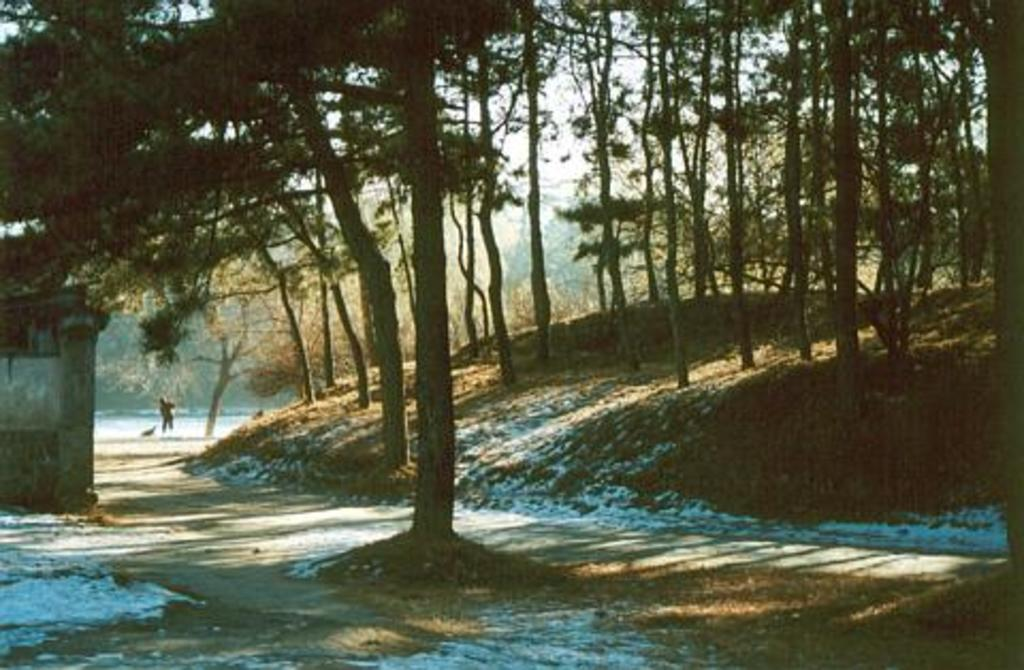What type of natural elements can be seen in the image? There are trees in the image. What type of structure is present in the image? There is a house in the image. Who is present in the image? There is a man in the image. What is the man doing in the image? The man is using a broom for cleaning. Where is the grandmother sitting with her pets in the image? There is no grandmother or pets present in the image. What type of cushion is the man using for cleaning in the image? The man is using a broom for cleaning, not a cushion. 